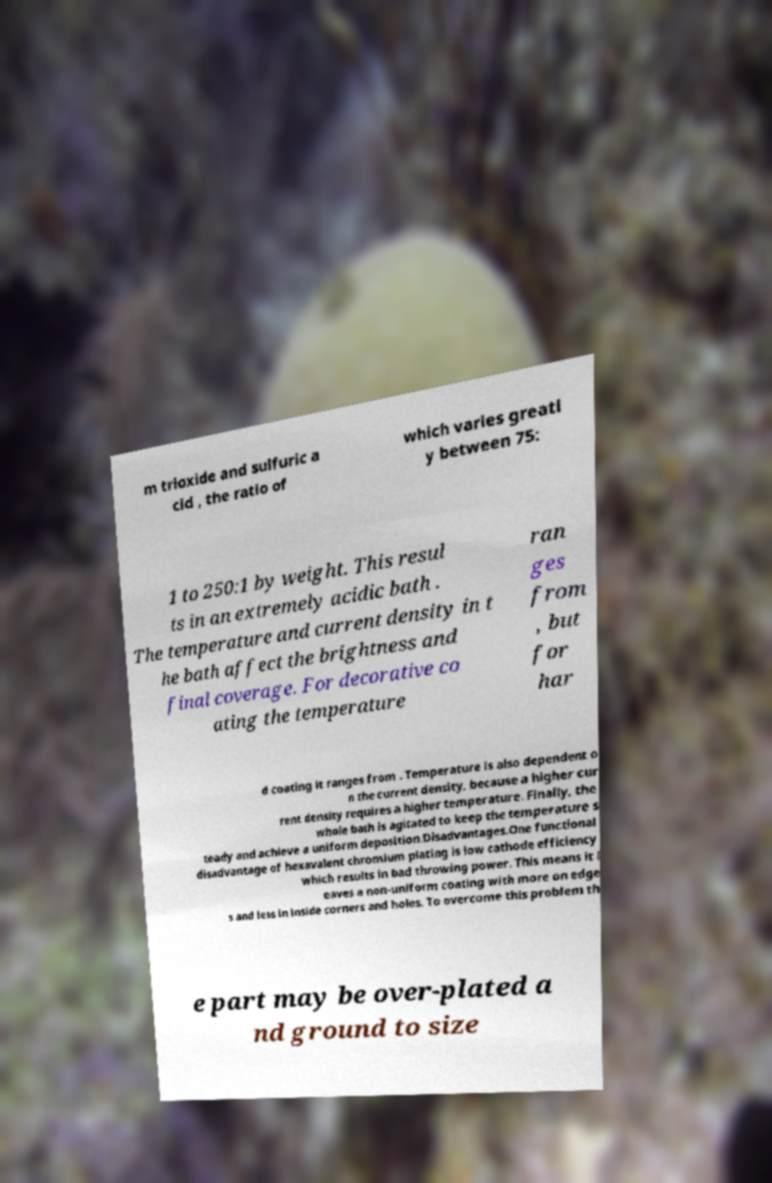Can you read and provide the text displayed in the image?This photo seems to have some interesting text. Can you extract and type it out for me? m trioxide and sulfuric a cid , the ratio of which varies greatl y between 75: 1 to 250:1 by weight. This resul ts in an extremely acidic bath . The temperature and current density in t he bath affect the brightness and final coverage. For decorative co ating the temperature ran ges from , but for har d coating it ranges from . Temperature is also dependent o n the current density, because a higher cur rent density requires a higher temperature. Finally, the whole bath is agitated to keep the temperature s teady and achieve a uniform deposition.Disadvantages.One functional disadvantage of hexavalent chromium plating is low cathode efficiency which results in bad throwing power. This means it l eaves a non-uniform coating with more on edge s and less in inside corners and holes. To overcome this problem th e part may be over-plated a nd ground to size 